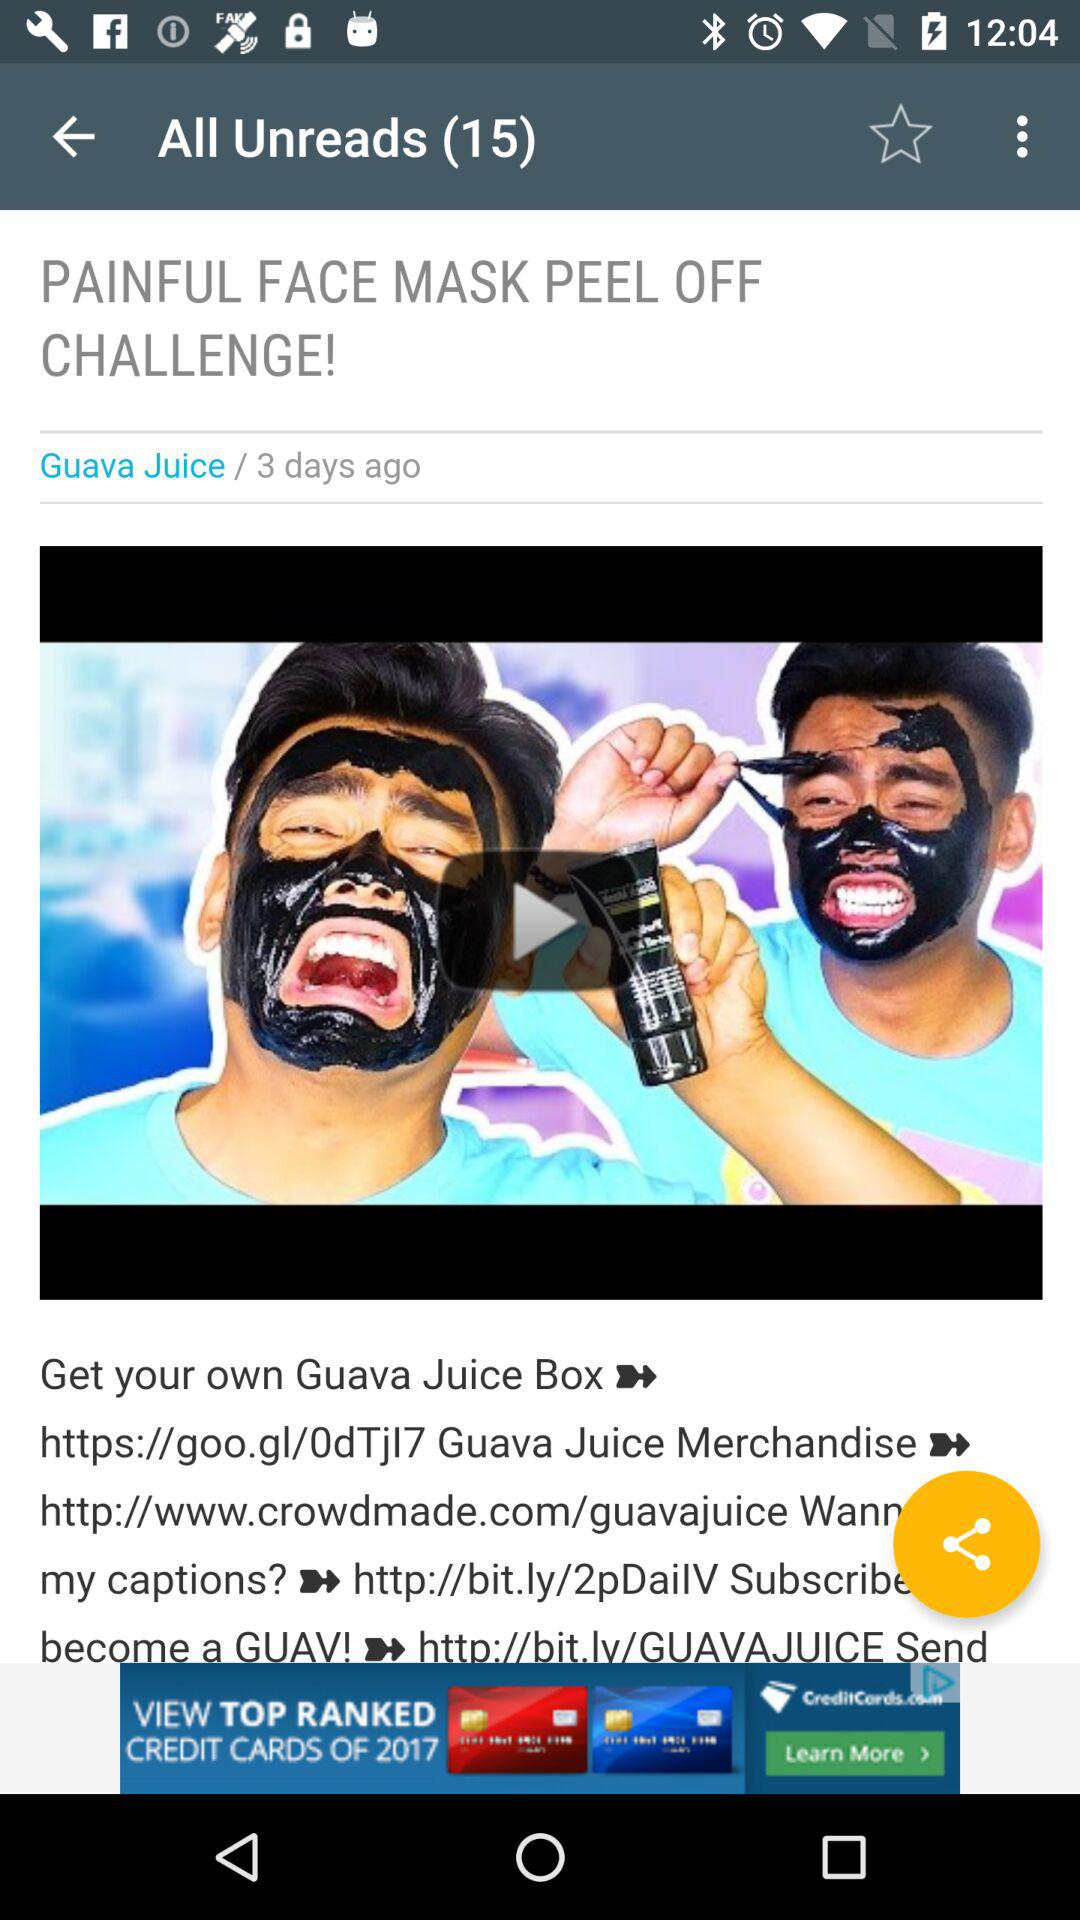When was the video posted? The video was posted 3 days ago. 